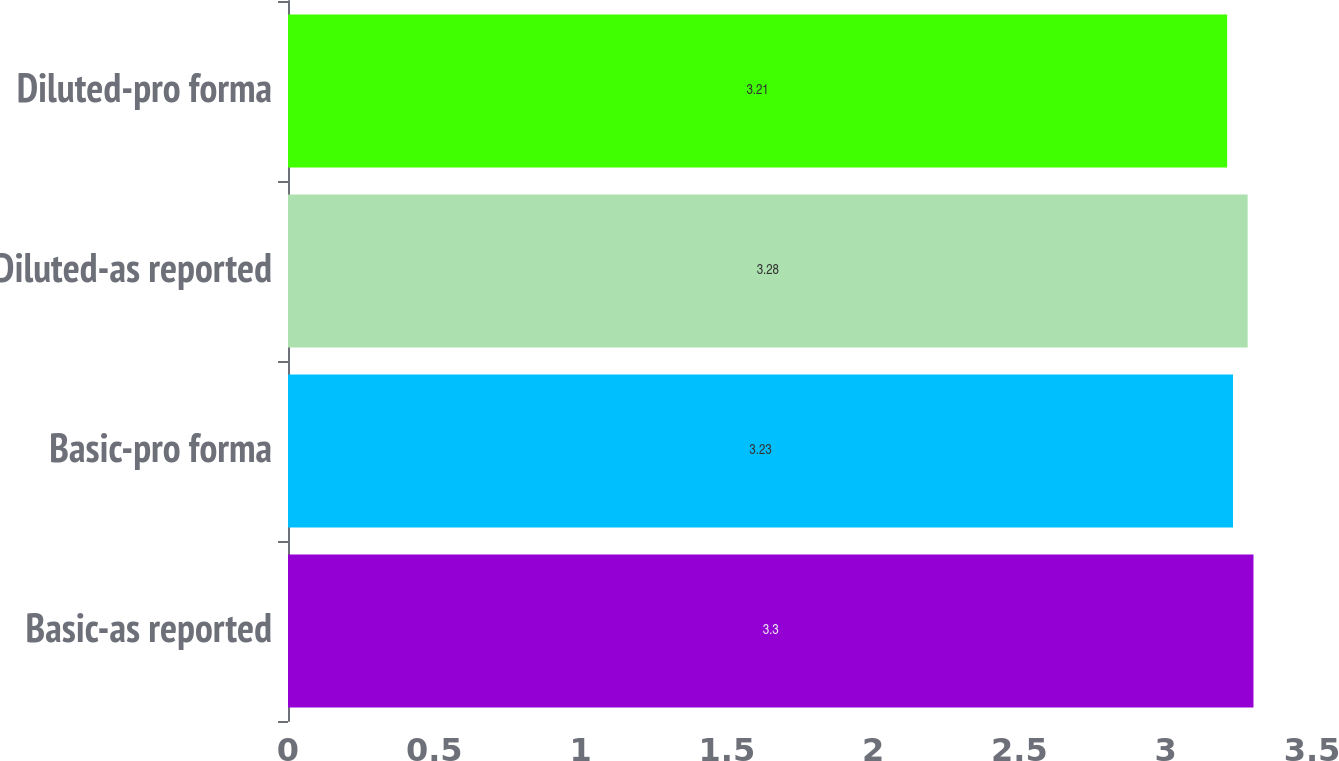<chart> <loc_0><loc_0><loc_500><loc_500><bar_chart><fcel>Basic-as reported<fcel>Basic-pro forma<fcel>Diluted-as reported<fcel>Diluted-pro forma<nl><fcel>3.3<fcel>3.23<fcel>3.28<fcel>3.21<nl></chart> 